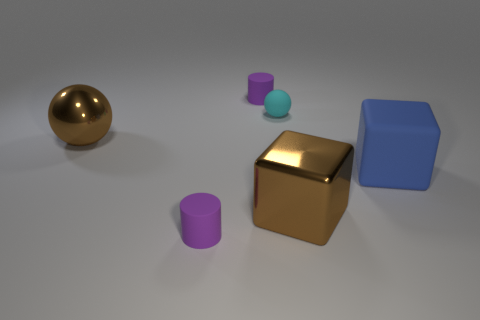What materials do the objects in the image seem to be made of? The objects appear to be made of different materials. The sphere looks like it is made of a polished metal, perhaps brass or gold, given its reflective quality and color. The cube in the center has a similar sheen and color, indicating it might be made of the same metal. The two identical cylinders and the remaining cube have matte surfaces, suggesting they could be made of a rubber-like material. 